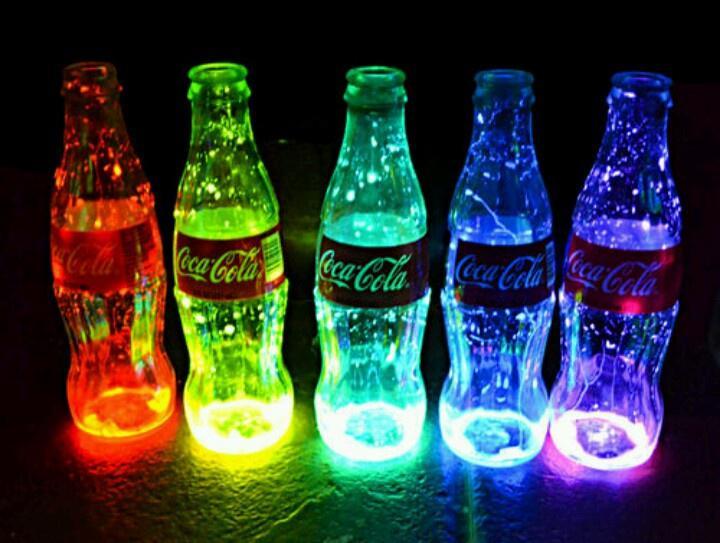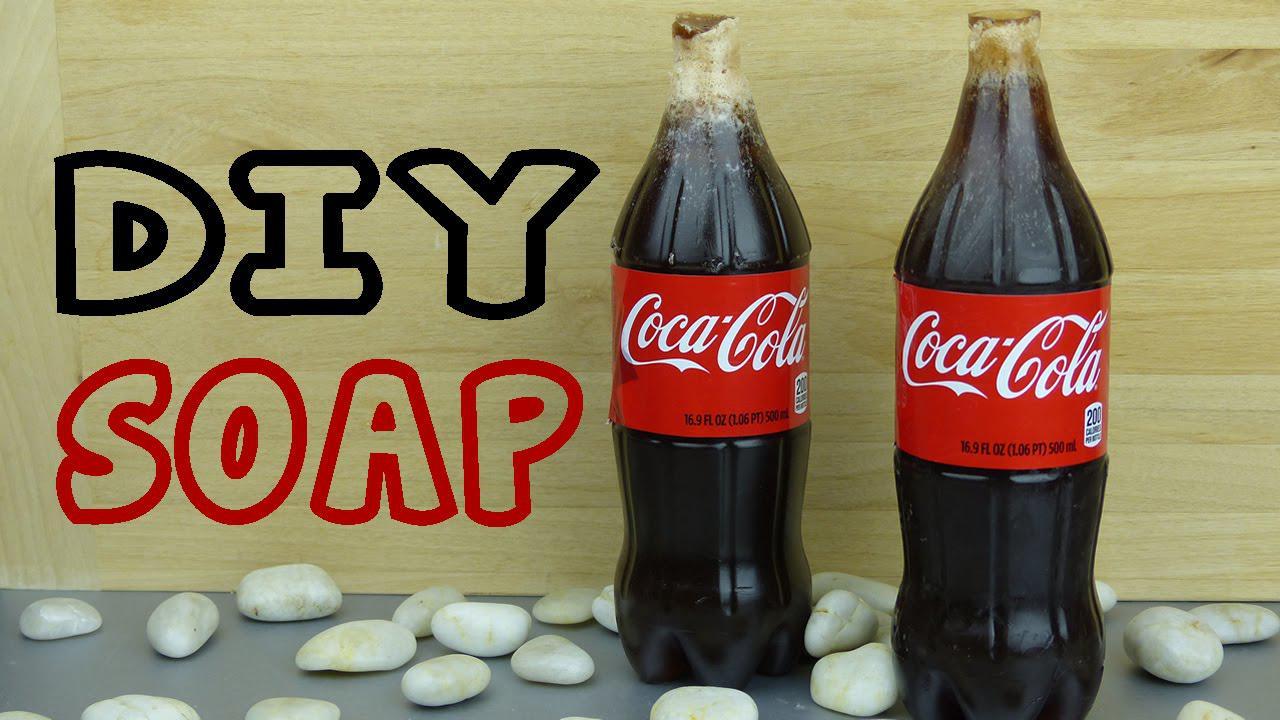The first image is the image on the left, the second image is the image on the right. Considering the images on both sides, is "The left and right image contains the same number of glass containers shaped like a bottle." valid? Answer yes or no. No. The first image is the image on the left, the second image is the image on the right. Evaluate the accuracy of this statement regarding the images: "One image includes at least one candle with a wick in an upright glass soda bottle with a red label and its neck cut off.". Is it true? Answer yes or no. No. 